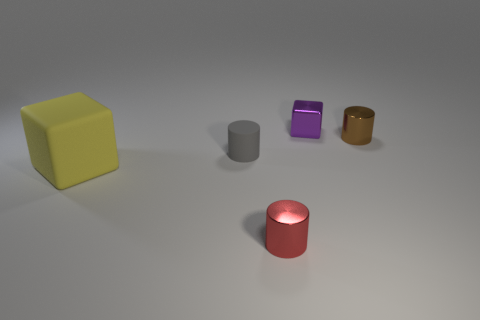Are there any other things that are the same size as the yellow matte cube?
Keep it short and to the point. No. What number of rubber things are either yellow things or tiny red things?
Your answer should be very brief. 1. The cube that is in front of the cube behind the yellow object is made of what material?
Offer a terse response. Rubber. How many objects are big green shiny blocks or metal objects that are in front of the gray cylinder?
Ensure brevity in your answer.  1. What size is the red cylinder that is made of the same material as the brown cylinder?
Keep it short and to the point. Small. What number of brown objects are tiny cylinders or small rubber objects?
Give a very brief answer. 1. Are there any other things that are the same material as the red object?
Make the answer very short. Yes. There is a small object left of the tiny red shiny thing; is its shape the same as the tiny red metal thing in front of the small gray rubber cylinder?
Provide a succinct answer. Yes. How many big red matte balls are there?
Your response must be concise. 0. What shape is the tiny red object that is made of the same material as the purple thing?
Keep it short and to the point. Cylinder. 